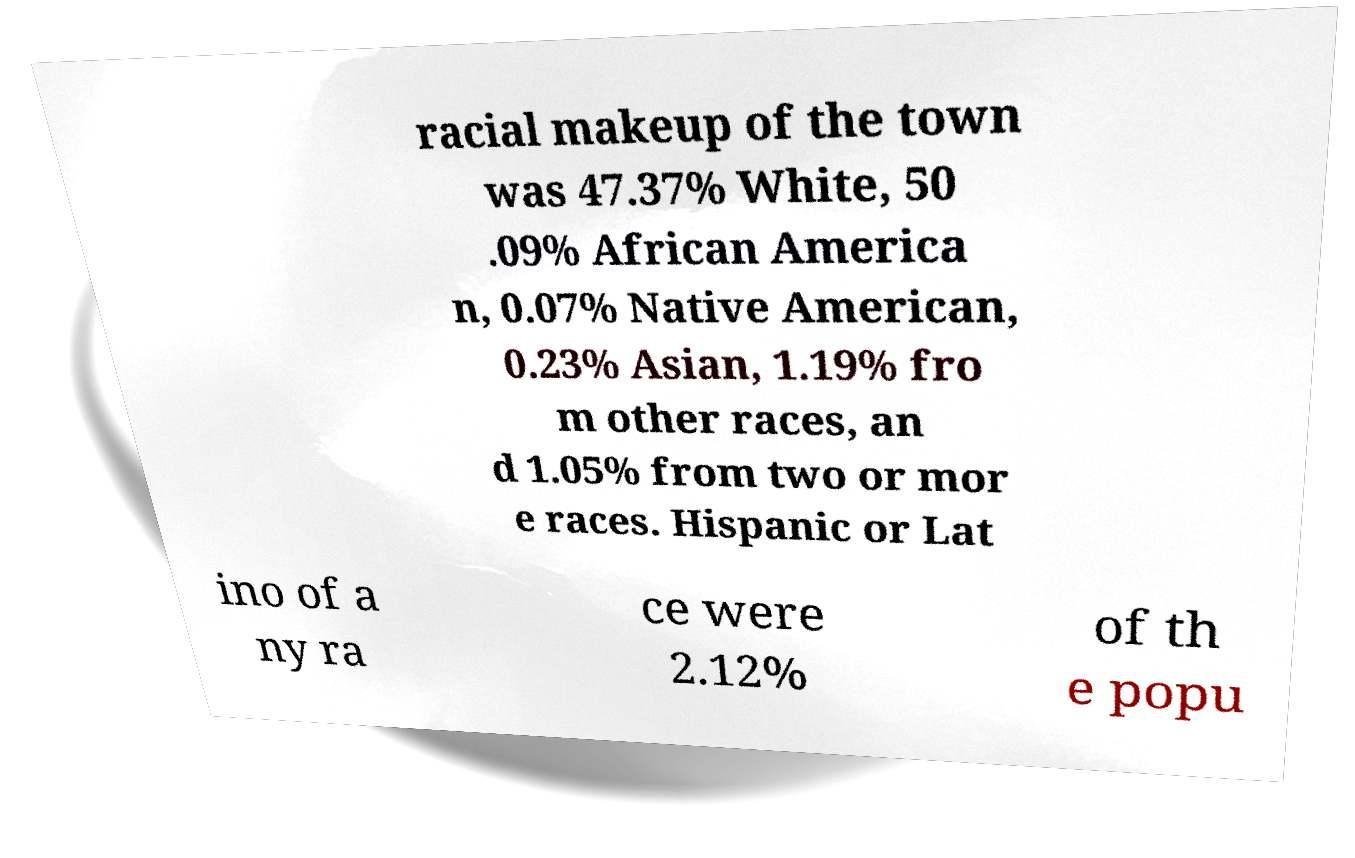Please identify and transcribe the text found in this image. racial makeup of the town was 47.37% White, 50 .09% African America n, 0.07% Native American, 0.23% Asian, 1.19% fro m other races, an d 1.05% from two or mor e races. Hispanic or Lat ino of a ny ra ce were 2.12% of th e popu 